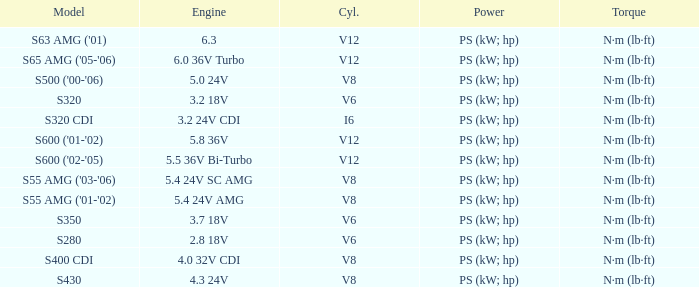Which engine is used in the s430 model? 4.3 24V. 